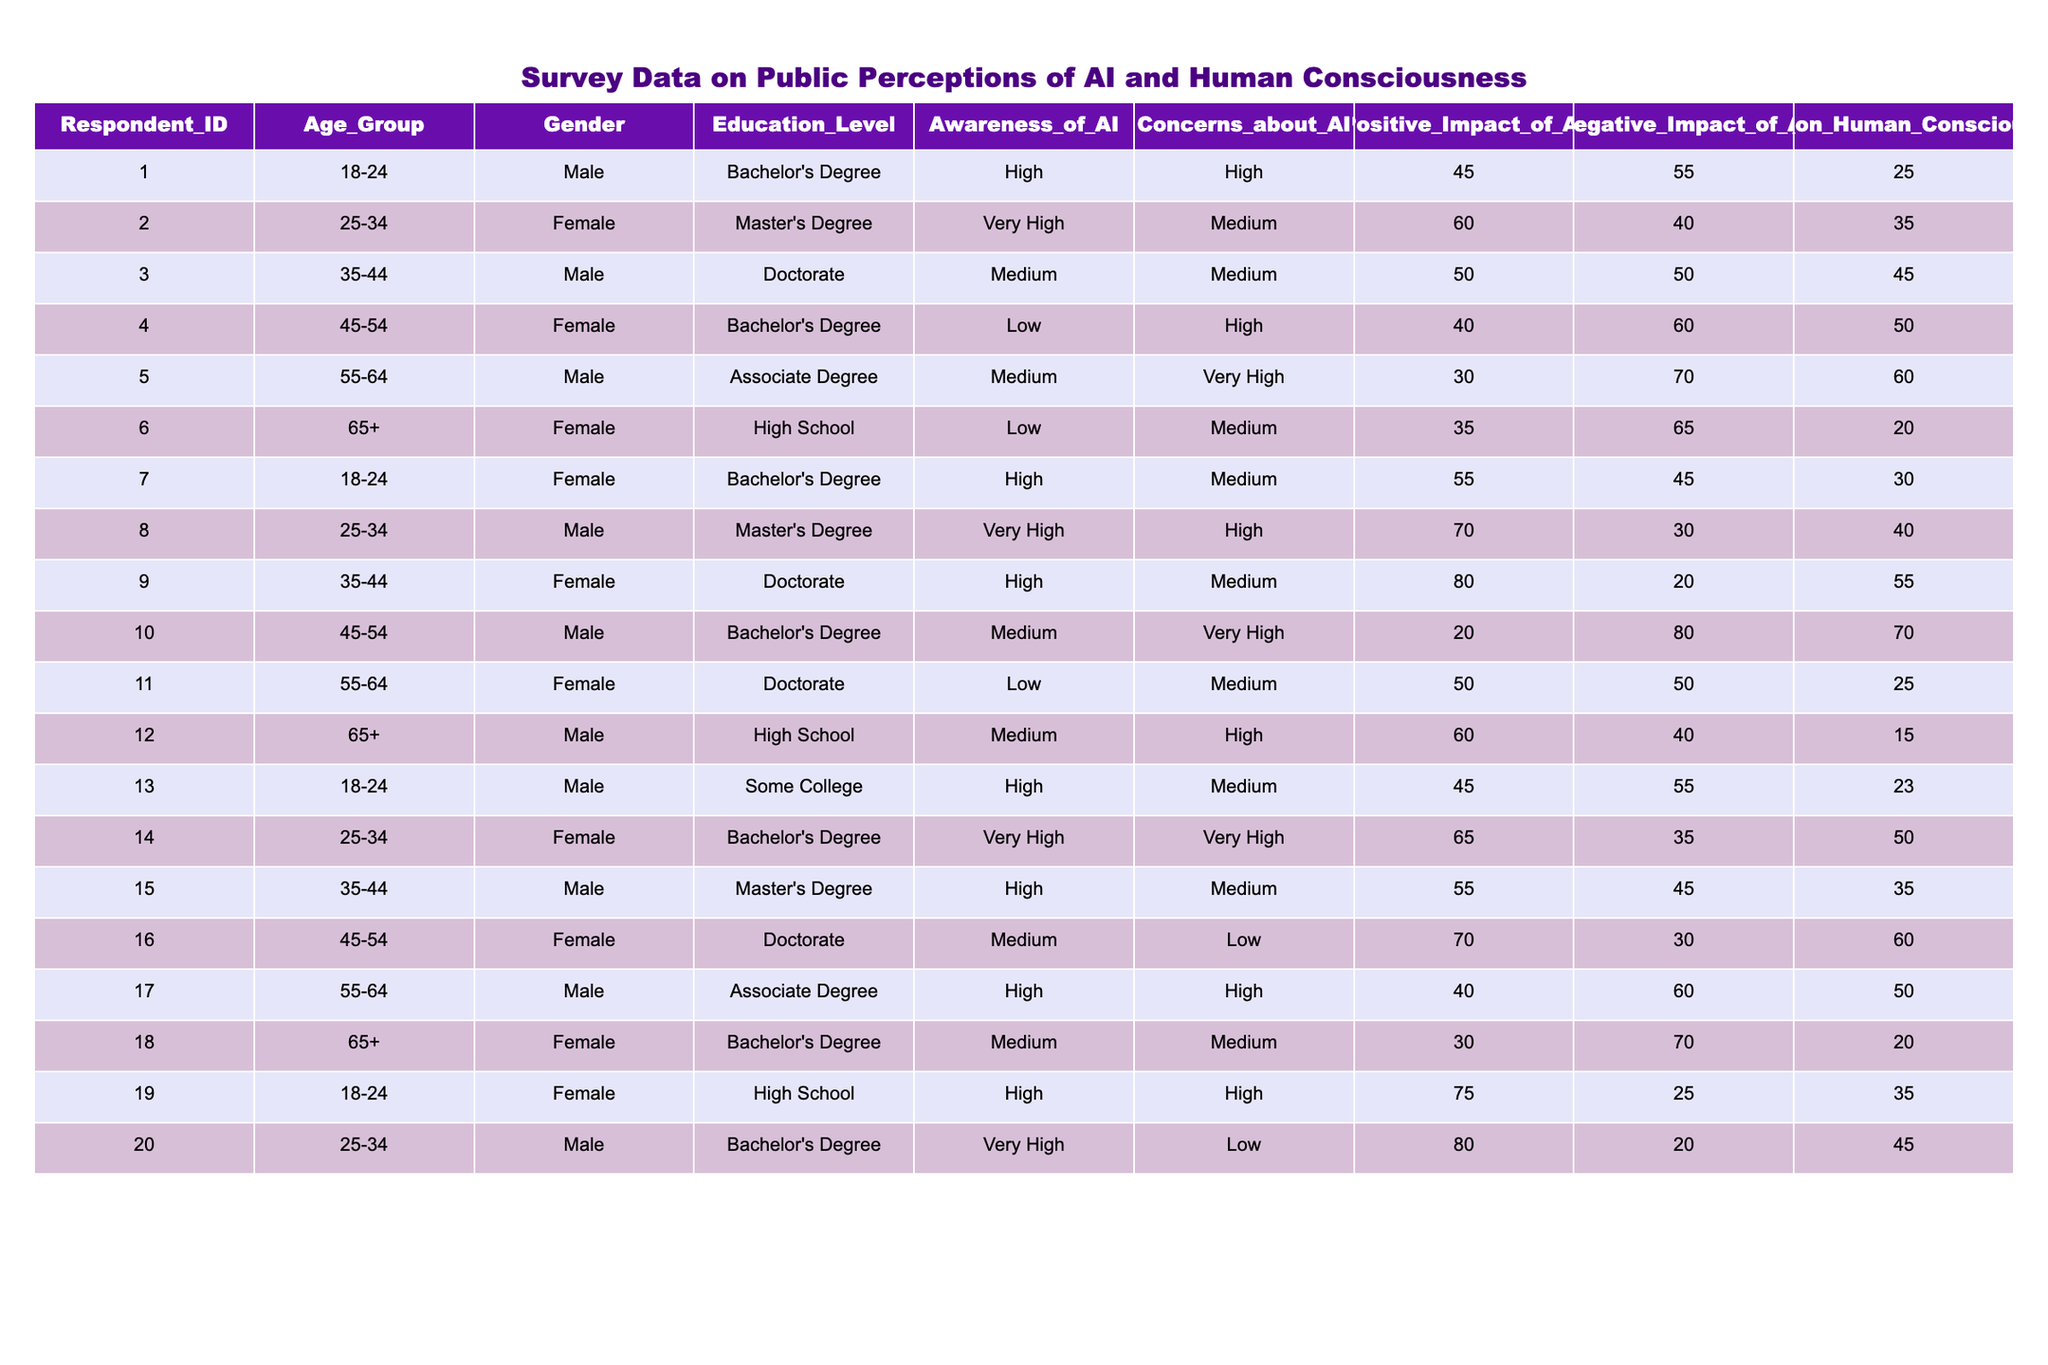What is the highest percentage of respondents who indicated a positive impact of AI? Looking at the column for "Positive_Impact_of_AI," the highest value is 80, which corresponds to respondents 9 and 20.
Answer: 80 What is the average negative impact score of AI for respondents aged 45-54? The respondents in the 45-54 age group have the negative impact scores of 60, 80, and 30. The sum is 60 + 80 + 30 = 170, and there are three respondents, so the average is 170 / 3 = 56.67.
Answer: 56.67 Is there any respondent with a very high awareness of AI who has a low concern about it? According to the table, respondents 2 and 8 have very high awareness but their concerns are medium and high respectively, indicating that no respondent fits this criterion.
Answer: No What percentage of respondents aged 55-64 expressed a high level of concern about AI? In the 55-64 age group, there are four respondents. Out of them, respondents 5 and 17 have high concerns, so the percentage is (2/4) * 100 = 50%.
Answer: 50% Which gender reported the highest average score for positive impacts of artificial intelligence? Analyzing the data per gender: males have scores of 45, 50, 30, 70, and 40 (average = 47); females have scores of 60, 80, 55, and 75 (average = 67.5). Since 67.5 is greater than 47, females reported a higher average.
Answer: Female What is the average effect of AI on human consciousness across all respondents? The effect scores are 25, 35, 45, 50, 60, 20, 30, 40, 55, 70, 25, 15, 23, 50, 35, 60, 50, 20, 35, and 45. Summing these gives 790. As there are 20 respondents, the average is 790 / 20 = 39.5.
Answer: 39.5 Do younger respondents (ages 18-24) have more positive perception scores on AI compared to older respondents (ages 55-64)? For 18-24, the average positive impact score is (45 + 55 + 75) / 3 = 58.33. For 55-64, the average is (30 + 50 + 40) / 3 = 40. Since 58.33 is greater than 40, younger respondents have a more positive perception.
Answer: Yes What is the overall concern level for respondents with a Doctorate education? The concerns for Doctorate holders are high, medium, very high, and low. This amounts to 2 high, 1 medium, and 1 low score. Compiling this, the majority (50%) show high concern.
Answer: Mostly high 